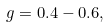Convert formula to latex. <formula><loc_0><loc_0><loc_500><loc_500>g = 0 . 4 - 0 . 6 ,</formula> 